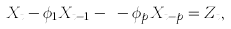Convert formula to latex. <formula><loc_0><loc_0><loc_500><loc_500>X _ { t } - \phi _ { 1 } X _ { t - 1 } - \dots - \phi _ { p } X _ { t - p } = Z _ { t } ,</formula> 